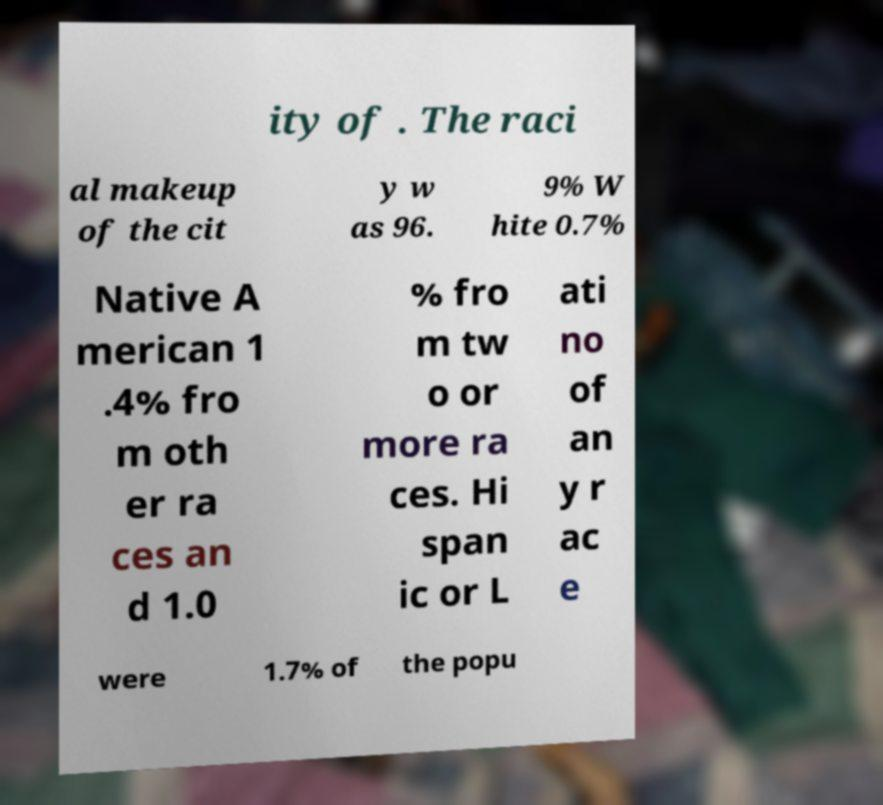Could you extract and type out the text from this image? ity of . The raci al makeup of the cit y w as 96. 9% W hite 0.7% Native A merican 1 .4% fro m oth er ra ces an d 1.0 % fro m tw o or more ra ces. Hi span ic or L ati no of an y r ac e were 1.7% of the popu 